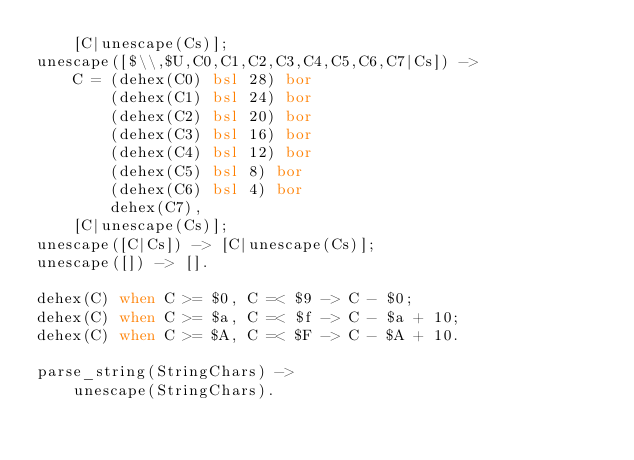<code> <loc_0><loc_0><loc_500><loc_500><_Erlang_>    [C|unescape(Cs)];
unescape([$\\,$U,C0,C1,C2,C3,C4,C5,C6,C7|Cs]) ->
    C = (dehex(C0) bsl 28) bor
        (dehex(C1) bsl 24) bor
        (dehex(C2) bsl 20) bor
        (dehex(C3) bsl 16) bor
        (dehex(C4) bsl 12) bor
        (dehex(C5) bsl 8) bor
        (dehex(C6) bsl 4) bor
        dehex(C7),
    [C|unescape(Cs)];
unescape([C|Cs]) -> [C|unescape(Cs)];
unescape([]) -> [].

dehex(C) when C >= $0, C =< $9 -> C - $0;
dehex(C) when C >= $a, C =< $f -> C - $a + 10;
dehex(C) when C >= $A, C =< $F -> C - $A + 10.

parse_string(StringChars) ->
    unescape(StringChars).
</code> 